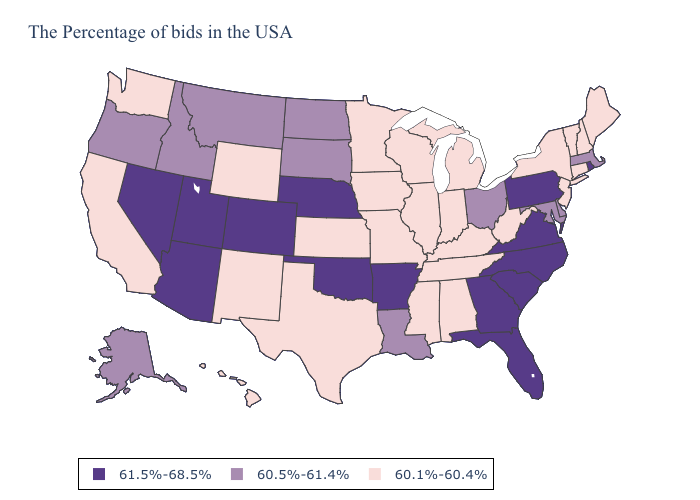Does Washington have the highest value in the USA?
Short answer required. No. What is the lowest value in the MidWest?
Short answer required. 60.1%-60.4%. What is the value of Michigan?
Write a very short answer. 60.1%-60.4%. What is the highest value in states that border Louisiana?
Short answer required. 61.5%-68.5%. Name the states that have a value in the range 60.1%-60.4%?
Keep it brief. Maine, New Hampshire, Vermont, Connecticut, New York, New Jersey, West Virginia, Michigan, Kentucky, Indiana, Alabama, Tennessee, Wisconsin, Illinois, Mississippi, Missouri, Minnesota, Iowa, Kansas, Texas, Wyoming, New Mexico, California, Washington, Hawaii. What is the value of West Virginia?
Quick response, please. 60.1%-60.4%. What is the value of Washington?
Short answer required. 60.1%-60.4%. What is the value of Oregon?
Answer briefly. 60.5%-61.4%. Name the states that have a value in the range 61.5%-68.5%?
Write a very short answer. Rhode Island, Pennsylvania, Virginia, North Carolina, South Carolina, Florida, Georgia, Arkansas, Nebraska, Oklahoma, Colorado, Utah, Arizona, Nevada. Name the states that have a value in the range 60.1%-60.4%?
Write a very short answer. Maine, New Hampshire, Vermont, Connecticut, New York, New Jersey, West Virginia, Michigan, Kentucky, Indiana, Alabama, Tennessee, Wisconsin, Illinois, Mississippi, Missouri, Minnesota, Iowa, Kansas, Texas, Wyoming, New Mexico, California, Washington, Hawaii. Among the states that border Virginia , which have the highest value?
Write a very short answer. North Carolina. Name the states that have a value in the range 60.5%-61.4%?
Short answer required. Massachusetts, Delaware, Maryland, Ohio, Louisiana, South Dakota, North Dakota, Montana, Idaho, Oregon, Alaska. Is the legend a continuous bar?
Quick response, please. No. What is the lowest value in the USA?
Be succinct. 60.1%-60.4%. Name the states that have a value in the range 60.5%-61.4%?
Quick response, please. Massachusetts, Delaware, Maryland, Ohio, Louisiana, South Dakota, North Dakota, Montana, Idaho, Oregon, Alaska. 